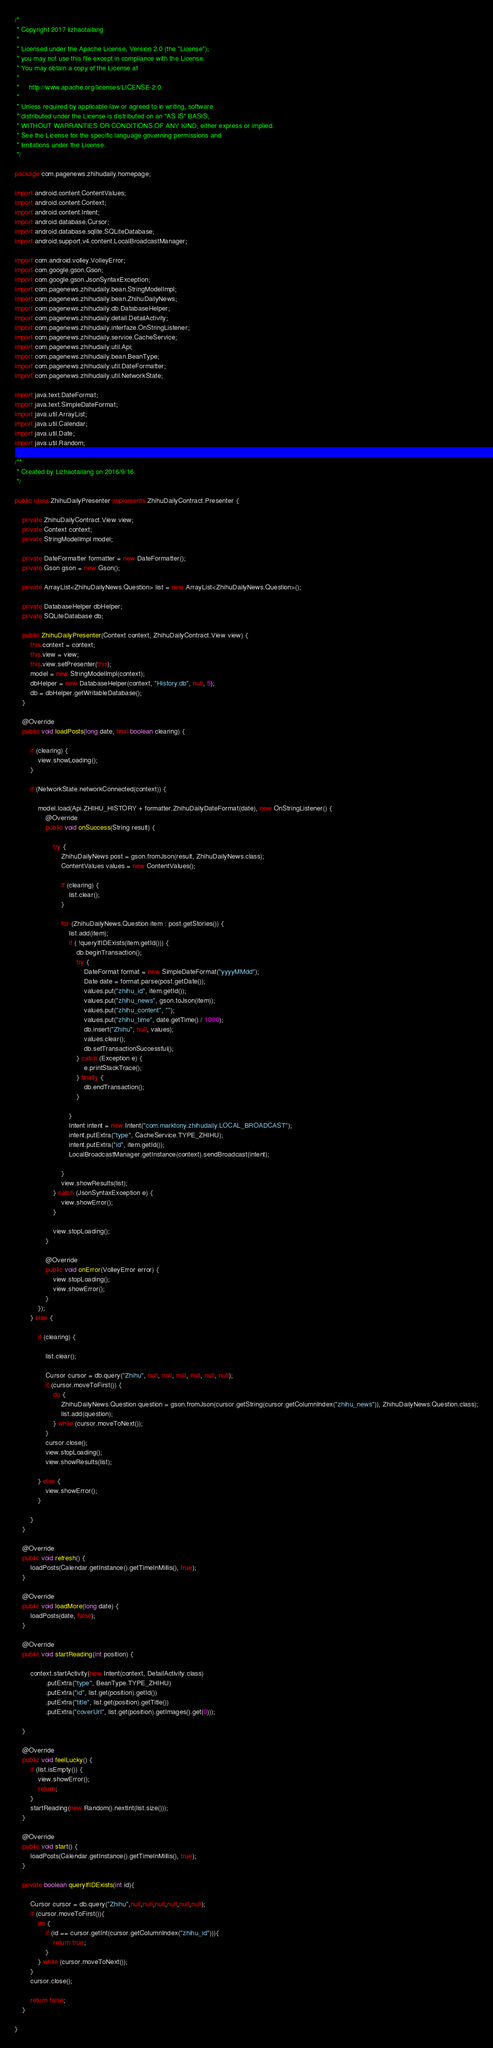Convert code to text. <code><loc_0><loc_0><loc_500><loc_500><_Java_>/*
 * Copyright 2017 lizhaotailang
 *
 * Licensed under the Apache License, Version 2.0 (the "License");
 * you may not use this file except in compliance with the License.
 * You may obtain a copy of the License at
 *
 *     http://www.apache.org/licenses/LICENSE-2.0
 *
 * Unless required by applicable law or agreed to in writing, software
 * distributed under the License is distributed on an "AS IS" BASIS,
 * WITHOUT WARRANTIES OR CONDITIONS OF ANY KIND, either express or implied.
 * See the License for the specific language governing permissions and
 * limitations under the License.
 */

package com.pagenews.zhihudaily.homepage;

import android.content.ContentValues;
import android.content.Context;
import android.content.Intent;
import android.database.Cursor;
import android.database.sqlite.SQLiteDatabase;
import android.support.v4.content.LocalBroadcastManager;

import com.android.volley.VolleyError;
import com.google.gson.Gson;
import com.google.gson.JsonSyntaxException;
import com.pagenews.zhihudaily.bean.StringModelImpl;
import com.pagenews.zhihudaily.bean.ZhihuDailyNews;
import com.pagenews.zhihudaily.db.DatabaseHelper;
import com.pagenews.zhihudaily.detail.DetailActivity;
import com.pagenews.zhihudaily.interfaze.OnStringListener;
import com.pagenews.zhihudaily.service.CacheService;
import com.pagenews.zhihudaily.util.Api;
import com.pagenews.zhihudaily.bean.BeanType;
import com.pagenews.zhihudaily.util.DateFormatter;
import com.pagenews.zhihudaily.util.NetworkState;

import java.text.DateFormat;
import java.text.SimpleDateFormat;
import java.util.ArrayList;
import java.util.Calendar;
import java.util.Date;
import java.util.Random;

/**
 * Created by Lizhaotailang on 2016/9/16.
 */

public class ZhihuDailyPresenter implements ZhihuDailyContract.Presenter {

    private ZhihuDailyContract.View view;
    private Context context;
    private StringModelImpl model;

    private DateFormatter formatter = new DateFormatter();
    private Gson gson = new Gson();

    private ArrayList<ZhihuDailyNews.Question> list = new ArrayList<ZhihuDailyNews.Question>();

    private DatabaseHelper dbHelper;
    private SQLiteDatabase db;

    public ZhihuDailyPresenter(Context context, ZhihuDailyContract.View view) {
        this.context = context;
        this.view = view;
        this.view.setPresenter(this);
        model = new StringModelImpl(context);
        dbHelper = new DatabaseHelper(context, "History.db", null, 5);
        db = dbHelper.getWritableDatabase();
    }

    @Override
    public void loadPosts(long date, final boolean clearing) {

        if (clearing) {
            view.showLoading();
        }

        if (NetworkState.networkConnected(context)) {

            model.load(Api.ZHIHU_HISTORY + formatter.ZhihuDailyDateFormat(date), new OnStringListener() {
                @Override
                public void onSuccess(String result) {

                    try {
                        ZhihuDailyNews post = gson.fromJson(result, ZhihuDailyNews.class);
                        ContentValues values = new ContentValues();

                        if (clearing) {
                            list.clear();
                        }

                        for (ZhihuDailyNews.Question item : post.getStories()) {
                            list.add(item);
                            if ( !queryIfIDExists(item.getId())) {
                                db.beginTransaction();
                                try {
                                    DateFormat format = new SimpleDateFormat("yyyyMMdd");
                                    Date date = format.parse(post.getDate());
                                    values.put("zhihu_id", item.getId());
                                    values.put("zhihu_news", gson.toJson(item));
                                    values.put("zhihu_content", "");
                                    values.put("zhihu_time", date.getTime() / 1000);
                                    db.insert("Zhihu", null, values);
                                    values.clear();
                                    db.setTransactionSuccessful();
                                } catch (Exception e) {
                                    e.printStackTrace();
                                } finally {
                                    db.endTransaction();
                                }

                            }
                            Intent intent = new Intent("com.marktony.zhihudaily.LOCAL_BROADCAST");
                            intent.putExtra("type", CacheService.TYPE_ZHIHU);
                            intent.putExtra("id", item.getId());
                            LocalBroadcastManager.getInstance(context).sendBroadcast(intent);

                        }
                        view.showResults(list);
                    } catch (JsonSyntaxException e) {
                        view.showError();
                    }

                    view.stopLoading();
                }

                @Override
                public void onError(VolleyError error) {
                    view.stopLoading();
                    view.showError();
                }
            });
        } else {

            if (clearing) {

                list.clear();

                Cursor cursor = db.query("Zhihu", null, null, null, null, null, null);
                if (cursor.moveToFirst()) {
                    do {
                        ZhihuDailyNews.Question question = gson.fromJson(cursor.getString(cursor.getColumnIndex("zhihu_news")), ZhihuDailyNews.Question.class);
                        list.add(question);
                    } while (cursor.moveToNext());
                }
                cursor.close();
                view.stopLoading();
                view.showResults(list);

            } else {
                view.showError();
            }

        }
    }

    @Override
    public void refresh() {
        loadPosts(Calendar.getInstance().getTimeInMillis(), true);
    }

    @Override
    public void loadMore(long date) {
        loadPosts(date, false);
    }

    @Override
    public void startReading(int position) {

        context.startActivity(new Intent(context, DetailActivity.class)
                .putExtra("type", BeanType.TYPE_ZHIHU)
                .putExtra("id", list.get(position).getId())
                .putExtra("title", list.get(position).getTitle())
                .putExtra("coverUrl", list.get(position).getImages().get(0)));

    }

    @Override
    public void feelLucky() {
        if (list.isEmpty()) {
            view.showError();
            return;
        }
        startReading(new Random().nextInt(list.size()));
    }

    @Override
    public void start() {
        loadPosts(Calendar.getInstance().getTimeInMillis(), true);
    }

    private boolean queryIfIDExists(int id){

        Cursor cursor = db.query("Zhihu",null,null,null,null,null,null);
        if (cursor.moveToFirst()){
            do {
                if (id == cursor.getInt(cursor.getColumnIndex("zhihu_id"))){
                    return true;
                }
            } while (cursor.moveToNext());
        }
        cursor.close();

        return false;
    }

}
</code> 